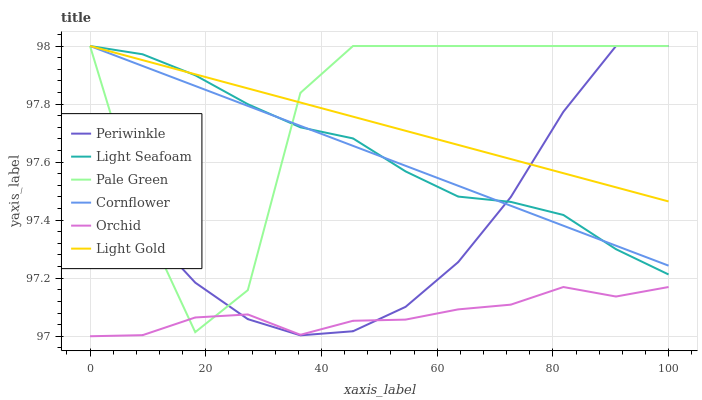Does Periwinkle have the minimum area under the curve?
Answer yes or no. No. Does Periwinkle have the maximum area under the curve?
Answer yes or no. No. Is Periwinkle the smoothest?
Answer yes or no. No. Is Periwinkle the roughest?
Answer yes or no. No. Does Pale Green have the lowest value?
Answer yes or no. No. Does Orchid have the highest value?
Answer yes or no. No. Is Orchid less than Light Seafoam?
Answer yes or no. Yes. Is Light Seafoam greater than Orchid?
Answer yes or no. Yes. Does Orchid intersect Light Seafoam?
Answer yes or no. No. 